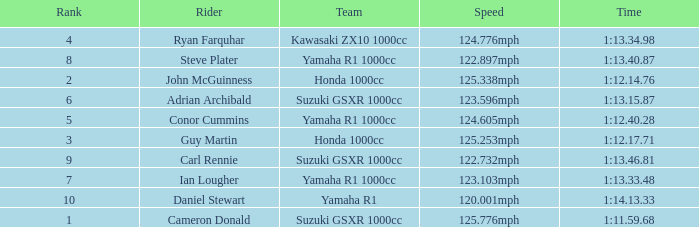What time did team kawasaki zx10 1000cc have? 1:13.34.98. 